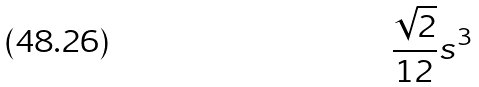Convert formula to latex. <formula><loc_0><loc_0><loc_500><loc_500>\frac { \sqrt { 2 } } { 1 2 } s ^ { 3 }</formula> 